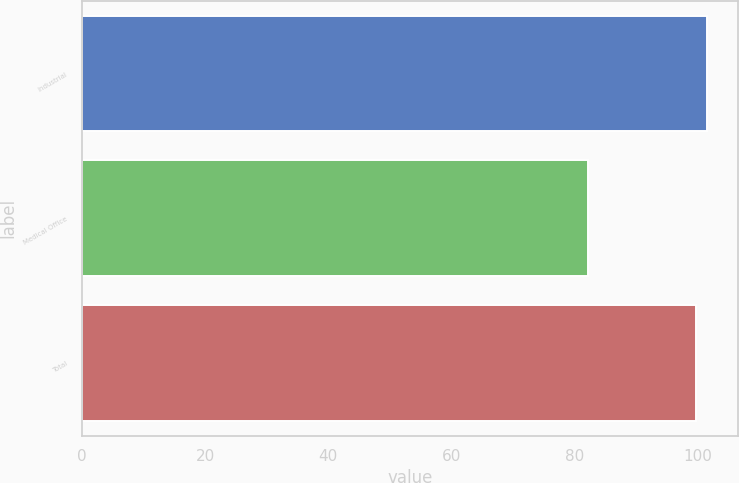<chart> <loc_0><loc_0><loc_500><loc_500><bar_chart><fcel>Industrial<fcel>Medical Office<fcel>Total<nl><fcel>101.57<fcel>82.3<fcel>99.8<nl></chart> 